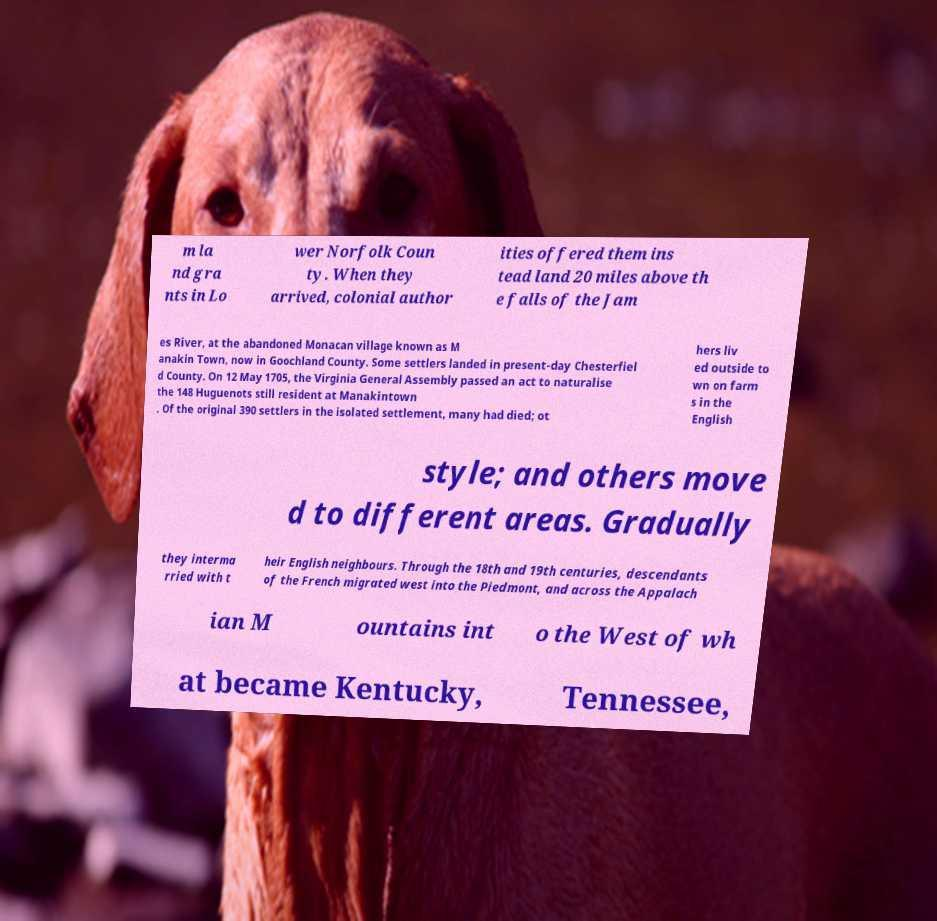Can you accurately transcribe the text from the provided image for me? m la nd gra nts in Lo wer Norfolk Coun ty. When they arrived, colonial author ities offered them ins tead land 20 miles above th e falls of the Jam es River, at the abandoned Monacan village known as M anakin Town, now in Goochland County. Some settlers landed in present-day Chesterfiel d County. On 12 May 1705, the Virginia General Assembly passed an act to naturalise the 148 Huguenots still resident at Manakintown . Of the original 390 settlers in the isolated settlement, many had died; ot hers liv ed outside to wn on farm s in the English style; and others move d to different areas. Gradually they interma rried with t heir English neighbours. Through the 18th and 19th centuries, descendants of the French migrated west into the Piedmont, and across the Appalach ian M ountains int o the West of wh at became Kentucky, Tennessee, 